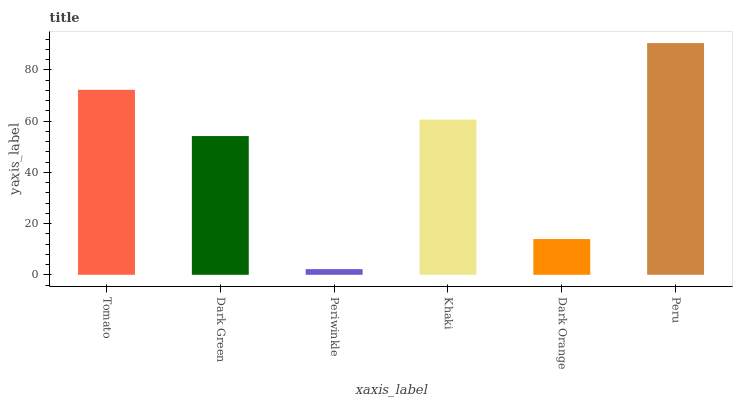Is Dark Green the minimum?
Answer yes or no. No. Is Dark Green the maximum?
Answer yes or no. No. Is Tomato greater than Dark Green?
Answer yes or no. Yes. Is Dark Green less than Tomato?
Answer yes or no. Yes. Is Dark Green greater than Tomato?
Answer yes or no. No. Is Tomato less than Dark Green?
Answer yes or no. No. Is Khaki the high median?
Answer yes or no. Yes. Is Dark Green the low median?
Answer yes or no. Yes. Is Periwinkle the high median?
Answer yes or no. No. Is Khaki the low median?
Answer yes or no. No. 